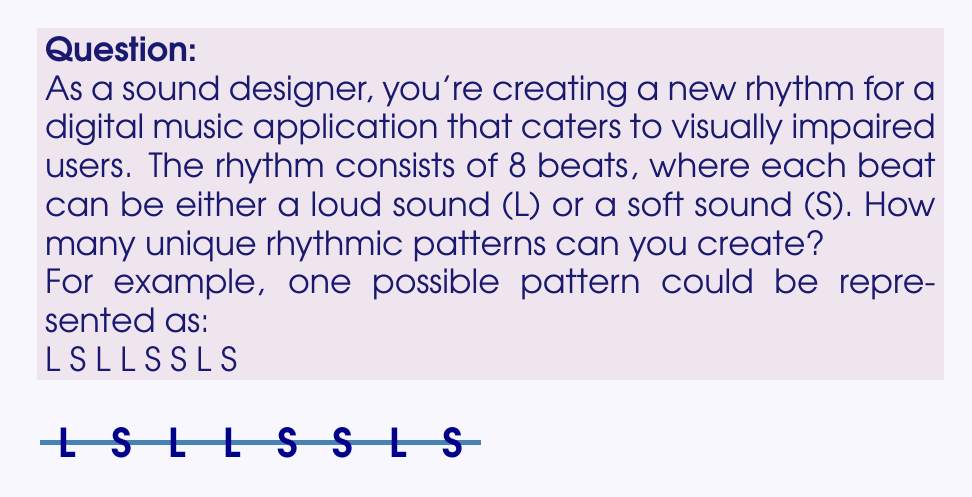Give your solution to this math problem. Let's approach this step-by-step:

1) We have 8 beats in total, and for each beat, we have 2 choices: Loud (L) or Soft (S).

2) This scenario is a perfect example of the multiplication principle in combinatorics. When we have a sequence of independent choices, we multiply the number of possibilities for each choice.

3) In this case, we have 8 independent choices (one for each beat), and each choice has 2 possibilities.

4) Therefore, the total number of possible patterns is:

   $$ 2 \times 2 \times 2 \times 2 \times 2 \times 2 \times 2 \times 2 = 2^8 $$

5) We can calculate this:

   $$ 2^8 = 256 $$

6) This means there are 256 unique rhythmic patterns that can be created using 8 beats, where each beat can be either loud or soft.

This large number of possibilities allows for a wide variety of rhythms, providing rich auditory experiences for visually impaired users of the digital music application.
Answer: $256$ 